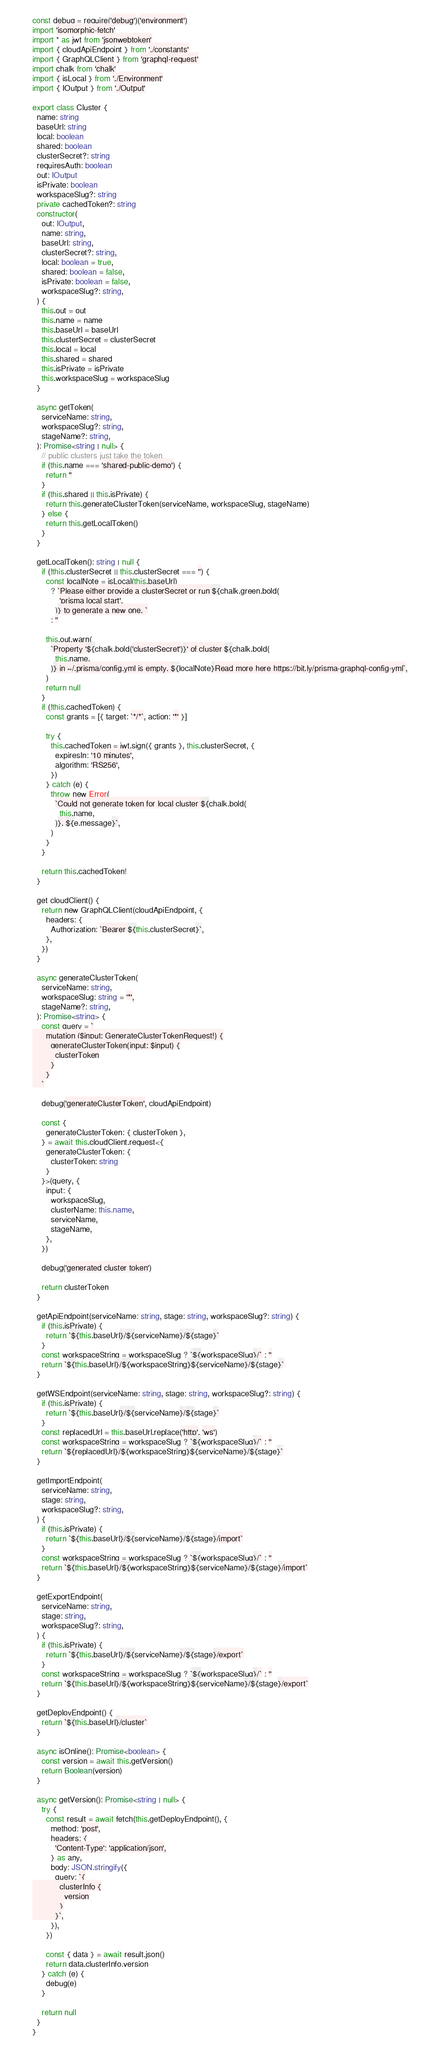Convert code to text. <code><loc_0><loc_0><loc_500><loc_500><_TypeScript_>const debug = require('debug')('environment')
import 'isomorphic-fetch'
import * as jwt from 'jsonwebtoken'
import { cloudApiEndpoint } from './constants'
import { GraphQLClient } from 'graphql-request'
import chalk from 'chalk'
import { isLocal } from './Environment'
import { IOutput } from './Output'

export class Cluster {
  name: string
  baseUrl: string
  local: boolean
  shared: boolean
  clusterSecret?: string
  requiresAuth: boolean
  out: IOutput
  isPrivate: boolean
  workspaceSlug?: string
  private cachedToken?: string
  constructor(
    out: IOutput,
    name: string,
    baseUrl: string,
    clusterSecret?: string,
    local: boolean = true,
    shared: boolean = false,
    isPrivate: boolean = false,
    workspaceSlug?: string,
  ) {
    this.out = out
    this.name = name
    this.baseUrl = baseUrl
    this.clusterSecret = clusterSecret
    this.local = local
    this.shared = shared
    this.isPrivate = isPrivate
    this.workspaceSlug = workspaceSlug
  }

  async getToken(
    serviceName: string,
    workspaceSlug?: string,
    stageName?: string,
  ): Promise<string | null> {
    // public clusters just take the token
    if (this.name === 'shared-public-demo') {
      return ''
    }
    if (this.shared || this.isPrivate) {
      return this.generateClusterToken(serviceName, workspaceSlug, stageName)
    } else {
      return this.getLocalToken()
    }
  }

  getLocalToken(): string | null {
    if (!this.clusterSecret || this.clusterSecret === '') {
      const localNote = isLocal(this.baseUrl)
        ? `Please either provide a clusterSecret or run ${chalk.green.bold(
            'prisma local start',
          )} to generate a new one. `
        : ''

      this.out.warn(
        `Property '${chalk.bold('clusterSecret')}' of cluster ${chalk.bold(
          this.name,
        )} in ~/.prisma/config.yml is empty. ${localNote}Read more here https://bit.ly/prisma-graphql-config-yml`,
      )
      return null
    }
    if (!this.cachedToken) {
      const grants = [{ target: `*/*`, action: '*' }]

      try {
        this.cachedToken = jwt.sign({ grants }, this.clusterSecret, {
          expiresIn: '10 minutes',
          algorithm: 'RS256',
        })
      } catch (e) {
        throw new Error(
          `Could not generate token for local cluster ${chalk.bold(
            this.name,
          )}. ${e.message}`,
        )
      }
    }

    return this.cachedToken!
  }

  get cloudClient() {
    return new GraphQLClient(cloudApiEndpoint, {
      headers: {
        Authorization: `Bearer ${this.clusterSecret}`,
      },
    })
  }

  async generateClusterToken(
    serviceName: string,
    workspaceSlug: string = '*',
    stageName?: string,
  ): Promise<string> {
    const query = `
      mutation ($input: GenerateClusterTokenRequest!) {
        generateClusterToken(input: $input) {
          clusterToken
        }
      }
    `

    debug('generateClusterToken', cloudApiEndpoint)

    const {
      generateClusterToken: { clusterToken },
    } = await this.cloudClient.request<{
      generateClusterToken: {
        clusterToken: string
      }
    }>(query, {
      input: {
        workspaceSlug,
        clusterName: this.name,
        serviceName,
        stageName,
      },
    })

    debug('generated cluster token')

    return clusterToken
  }

  getApiEndpoint(serviceName: string, stage: string, workspaceSlug?: string) {
    if (this.isPrivate) {
      return `${this.baseUrl}/${serviceName}/${stage}`
    }
    const workspaceString = workspaceSlug ? `${workspaceSlug}/` : ''
    return `${this.baseUrl}/${workspaceString}${serviceName}/${stage}`
  }

  getWSEndpoint(serviceName: string, stage: string, workspaceSlug?: string) {
    if (this.isPrivate) {
      return `${this.baseUrl}/${serviceName}/${stage}`
    }
    const replacedUrl = this.baseUrl.replace('http', 'ws')
    const workspaceString = workspaceSlug ? `${workspaceSlug}/` : ''
    return `${replacedUrl}/${workspaceString}${serviceName}/${stage}`
  }

  getImportEndpoint(
    serviceName: string,
    stage: string,
    workspaceSlug?: string,
  ) {
    if (this.isPrivate) {
      return `${this.baseUrl}/${serviceName}/${stage}/import`
    }
    const workspaceString = workspaceSlug ? `${workspaceSlug}/` : ''
    return `${this.baseUrl}/${workspaceString}${serviceName}/${stage}/import`
  }

  getExportEndpoint(
    serviceName: string,
    stage: string,
    workspaceSlug?: string,
  ) {
    if (this.isPrivate) {
      return `${this.baseUrl}/${serviceName}/${stage}/export`
    }
    const workspaceString = workspaceSlug ? `${workspaceSlug}/` : ''
    return `${this.baseUrl}/${workspaceString}${serviceName}/${stage}/export`
  }

  getDeployEndpoint() {
    return `${this.baseUrl}/cluster`
  }

  async isOnline(): Promise<boolean> {
    const version = await this.getVersion()
    return Boolean(version)
  }

  async getVersion(): Promise<string | null> {
    try {
      const result = await fetch(this.getDeployEndpoint(), {
        method: 'post',
        headers: {
          'Content-Type': 'application/json',
        } as any,
        body: JSON.stringify({
          query: `{
            clusterInfo {
              version
            }
          }`,
        }),
      })

      const { data } = await result.json()
      return data.clusterInfo.version
    } catch (e) {
      debug(e)
    }

    return null
  }
}
</code> 